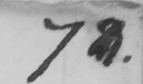Can you read and transcribe this handwriting? 7 8 